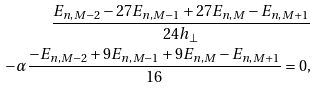<formula> <loc_0><loc_0><loc_500><loc_500>\frac { E _ { n , M - 2 } - 2 7 E _ { n , M - 1 } + 2 7 E _ { n , M } - E _ { n , M + 1 } } { 2 4 h _ { \perp } } \\ - \alpha \frac { - E _ { n , M - 2 } + 9 E _ { n , M - 1 } + 9 E _ { n , M } - E _ { n , M + 1 } } { 1 6 } = 0 ,</formula> 